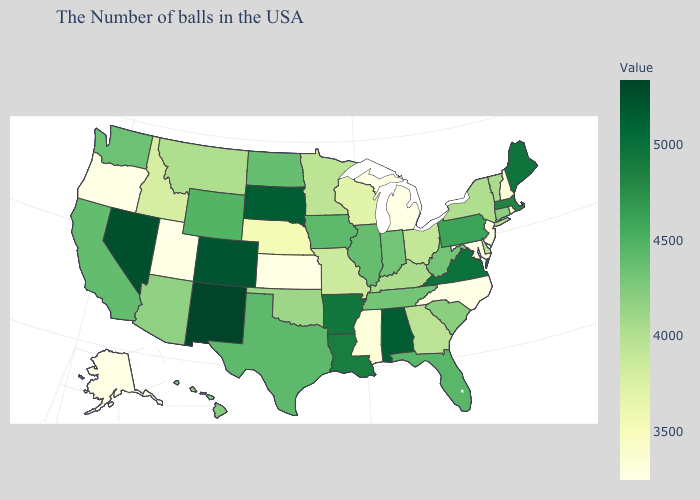Among the states that border Virginia , does Maryland have the lowest value?
Keep it brief. Yes. Among the states that border Iowa , which have the lowest value?
Quick response, please. Nebraska. Does the map have missing data?
Concise answer only. No. Which states have the lowest value in the USA?
Give a very brief answer. New Jersey, Maryland, North Carolina, Michigan, Kansas, Utah, Oregon, Alaska. 